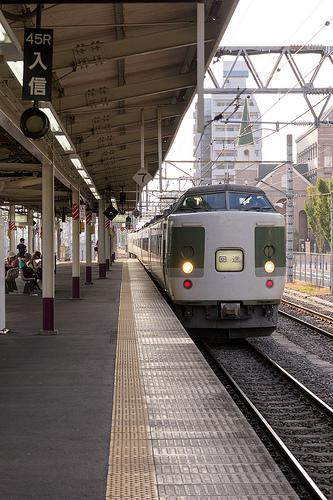Question: who waiting on benches on the left?
Choices:
A. Girls.
B. Woman.
C. People.
D. Ladies.
Answer with the letter. Answer: C Question: what mode of transport is shown?
Choices:
A. A car.
B. A skateboard.
C. A train.
D. A plane.
Answer with the letter. Answer: C Question: where was the picture taken?
Choices:
A. Air port.
B. Ocean.
C. Pond.
D. Train station.
Answer with the letter. Answer: D Question: how many trains are shown?
Choices:
A. 2.
B. 1.
C. 3.
D. 4.
Answer with the letter. Answer: B 